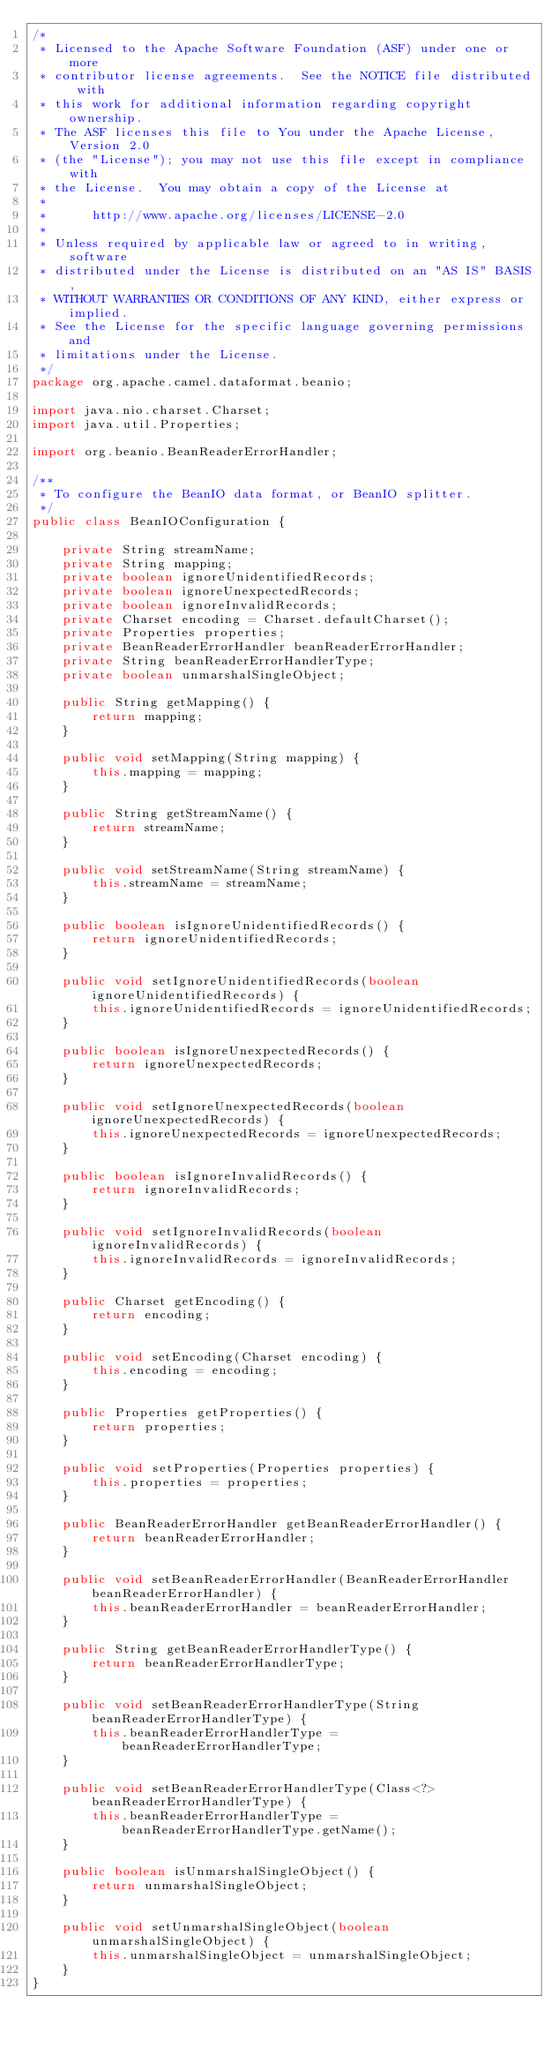Convert code to text. <code><loc_0><loc_0><loc_500><loc_500><_Java_>/*
 * Licensed to the Apache Software Foundation (ASF) under one or more
 * contributor license agreements.  See the NOTICE file distributed with
 * this work for additional information regarding copyright ownership.
 * The ASF licenses this file to You under the Apache License, Version 2.0
 * (the "License"); you may not use this file except in compliance with
 * the License.  You may obtain a copy of the License at
 *
 *      http://www.apache.org/licenses/LICENSE-2.0
 *
 * Unless required by applicable law or agreed to in writing, software
 * distributed under the License is distributed on an "AS IS" BASIS,
 * WITHOUT WARRANTIES OR CONDITIONS OF ANY KIND, either express or implied.
 * See the License for the specific language governing permissions and
 * limitations under the License.
 */
package org.apache.camel.dataformat.beanio;

import java.nio.charset.Charset;
import java.util.Properties;

import org.beanio.BeanReaderErrorHandler;

/**
 * To configure the BeanIO data format, or BeanIO splitter.
 */
public class BeanIOConfiguration {

    private String streamName;
    private String mapping;
    private boolean ignoreUnidentifiedRecords;
    private boolean ignoreUnexpectedRecords;
    private boolean ignoreInvalidRecords;
    private Charset encoding = Charset.defaultCharset();
    private Properties properties;
    private BeanReaderErrorHandler beanReaderErrorHandler;
    private String beanReaderErrorHandlerType;
    private boolean unmarshalSingleObject;

    public String getMapping() {
        return mapping;
    }

    public void setMapping(String mapping) {
        this.mapping = mapping;
    }

    public String getStreamName() {
        return streamName;
    }

    public void setStreamName(String streamName) {
        this.streamName = streamName;
    }

    public boolean isIgnoreUnidentifiedRecords() {
        return ignoreUnidentifiedRecords;
    }

    public void setIgnoreUnidentifiedRecords(boolean ignoreUnidentifiedRecords) {
        this.ignoreUnidentifiedRecords = ignoreUnidentifiedRecords;
    }

    public boolean isIgnoreUnexpectedRecords() {
        return ignoreUnexpectedRecords;
    }

    public void setIgnoreUnexpectedRecords(boolean ignoreUnexpectedRecords) {
        this.ignoreUnexpectedRecords = ignoreUnexpectedRecords;
    }

    public boolean isIgnoreInvalidRecords() {
        return ignoreInvalidRecords;
    }

    public void setIgnoreInvalidRecords(boolean ignoreInvalidRecords) {
        this.ignoreInvalidRecords = ignoreInvalidRecords;
    }

    public Charset getEncoding() {
        return encoding;
    }

    public void setEncoding(Charset encoding) {
        this.encoding = encoding;
    }

    public Properties getProperties() {
        return properties;
    }

    public void setProperties(Properties properties) {
        this.properties = properties;
    }

    public BeanReaderErrorHandler getBeanReaderErrorHandler() {
        return beanReaderErrorHandler;
    }

    public void setBeanReaderErrorHandler(BeanReaderErrorHandler beanReaderErrorHandler) {
        this.beanReaderErrorHandler = beanReaderErrorHandler;
    }

    public String getBeanReaderErrorHandlerType() {
        return beanReaderErrorHandlerType;
    }

    public void setBeanReaderErrorHandlerType(String beanReaderErrorHandlerType) {
        this.beanReaderErrorHandlerType = beanReaderErrorHandlerType;
    }

    public void setBeanReaderErrorHandlerType(Class<?> beanReaderErrorHandlerType) {
        this.beanReaderErrorHandlerType = beanReaderErrorHandlerType.getName();
    }

    public boolean isUnmarshalSingleObject() {
        return unmarshalSingleObject;
    }

    public void setUnmarshalSingleObject(boolean unmarshalSingleObject) {
        this.unmarshalSingleObject = unmarshalSingleObject;
    }
}
</code> 